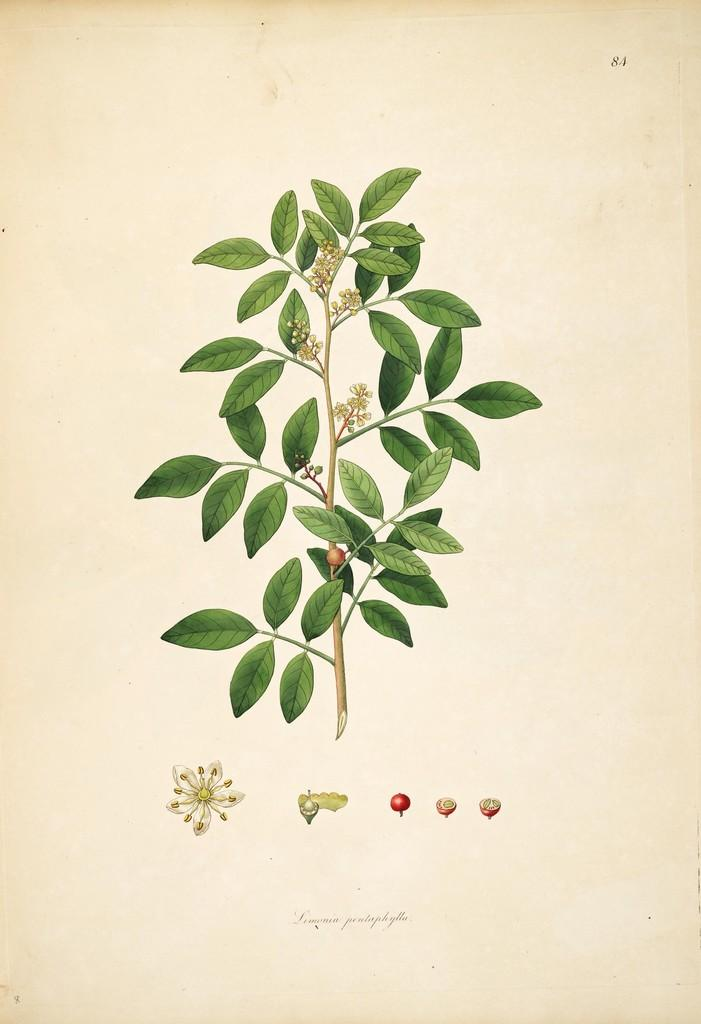What is depicted in the painting in the image? The painting contains a stem with leaves and branches, flowers, and fruits. Can you describe the flowers in the painting? The flowers in the painting are part of the stem with leaves and branches. What else is included in the painting besides the stem and flowers? There are fruits in the painting. What can be seen at the bottom of the image? The bottom of the image includes parts of flowers and flowers and fruits. What type of rose can be seen in the image? There is no rose present in the image; the painting features a stem with leaves, branches, flowers, and fruits. 